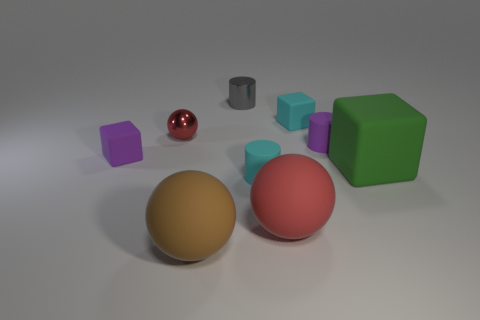Can you describe the arrangement and colors of the shapes in the image? Certainly! The image showcases a variety of 3D shapes with different colors distributed across a flat surface. There are two large spheres: one is glossy red and the other has a matte gold finish. A smaller, shiny red sphere mirrors the color of the larger one. There's also a green cube and three rectangular prisms—one is gray, while the others are cyan and purple. The background is neutral, ensuring the shapes and colors stand out. 